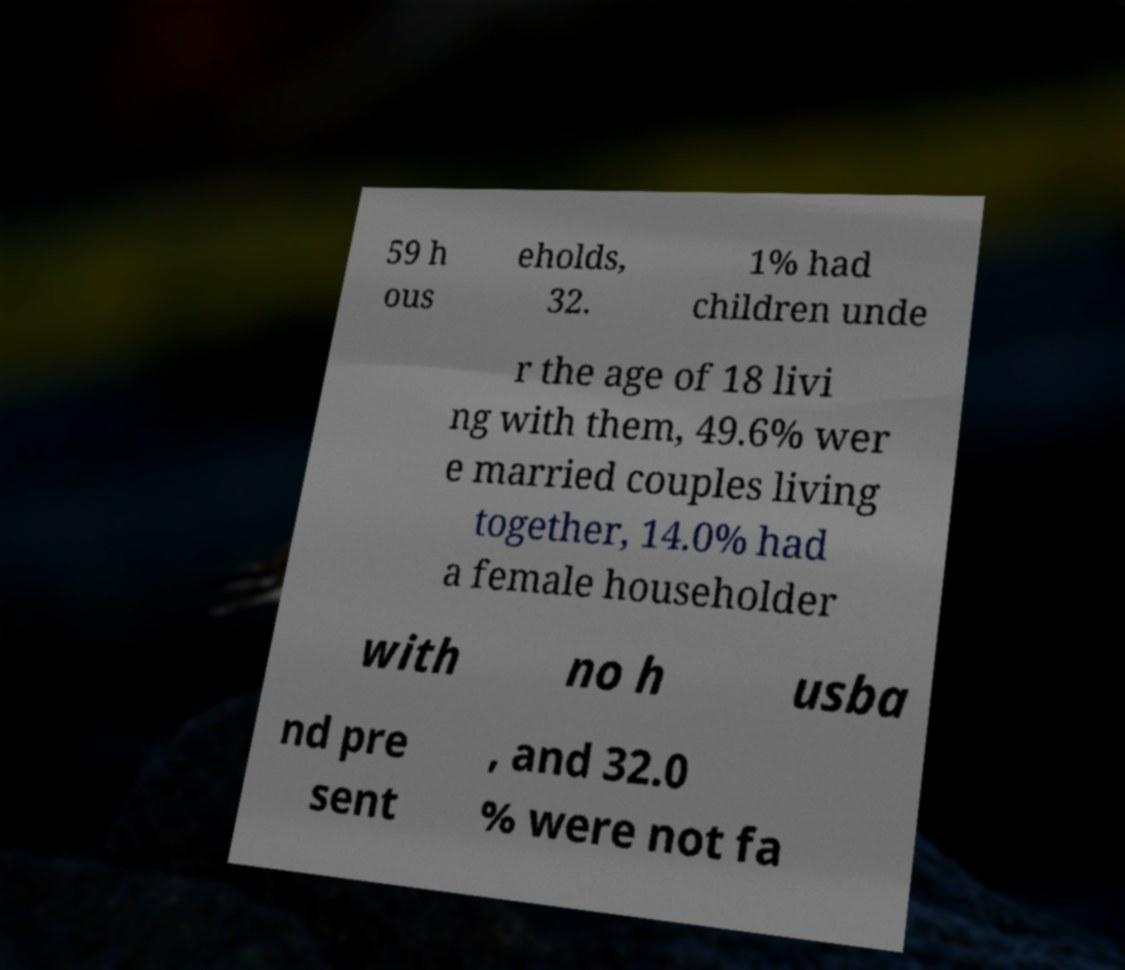What messages or text are displayed in this image? I need them in a readable, typed format. 59 h ous eholds, 32. 1% had children unde r the age of 18 livi ng with them, 49.6% wer e married couples living together, 14.0% had a female householder with no h usba nd pre sent , and 32.0 % were not fa 